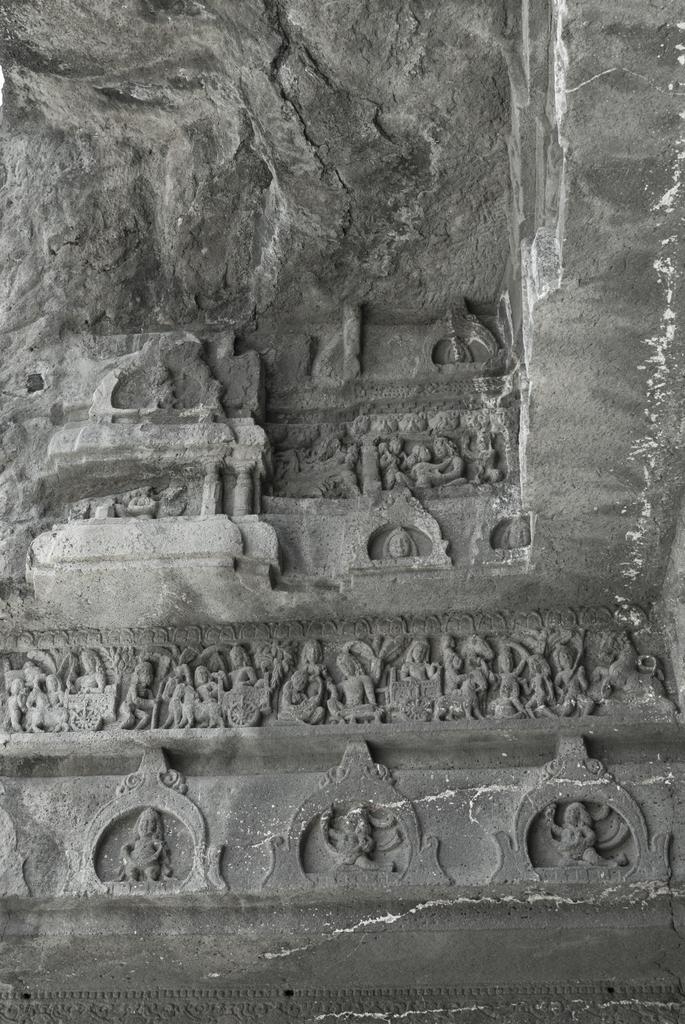Can you describe this image briefly? In this image there is a wall and we can see sculptures carved on the wall. 